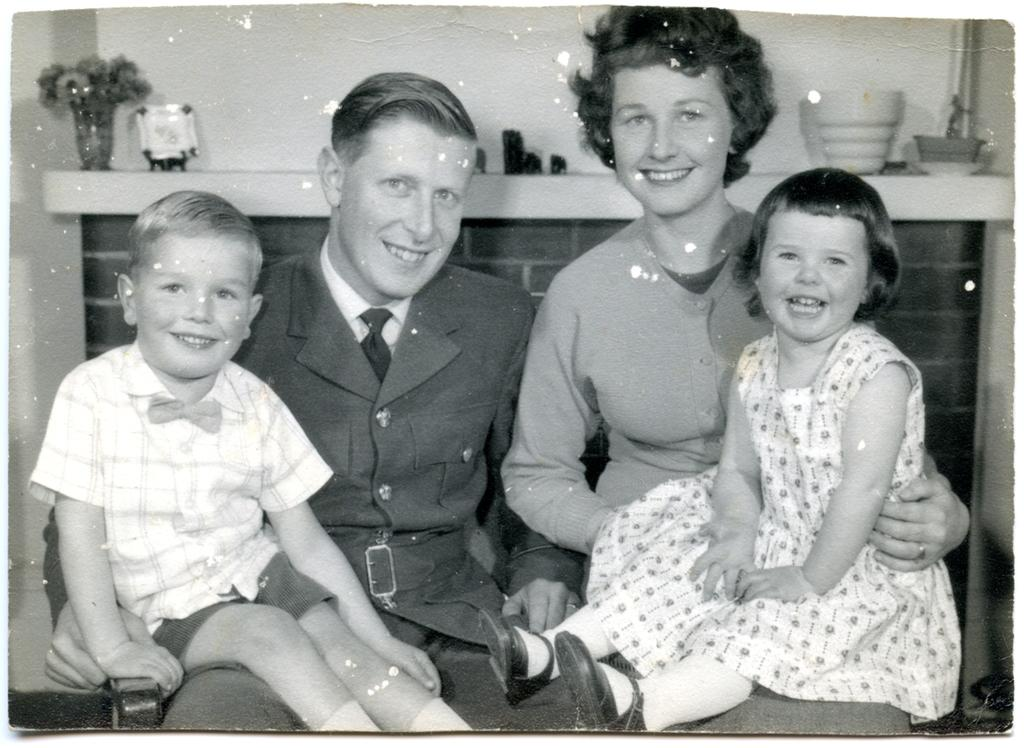Who is in the picture? There is a couple in the picture. What are the couple doing in the picture? The couple is sitting. Are there any children in the picture? Yes, there are two kids sitting on the couple. What else can be seen in the background of the picture? There are other objects visible in the background. What type of food is the couple sorting in the picture? There is no indication in the image that the couple is sorting any food; they are simply sitting with two kids on their laps. 